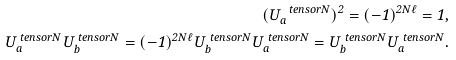Convert formula to latex. <formula><loc_0><loc_0><loc_500><loc_500>( U _ { a } ^ { \ t e n s o r N } ) ^ { 2 } = ( - 1 ) ^ { 2 N \ell } = 1 , \\ U _ { a } ^ { \ t e n s o r N } U _ { b } ^ { \ t e n s o r N } = ( - 1 ) ^ { 2 N \ell } U _ { b } ^ { \ t e n s o r N } U _ { a } ^ { \ t e n s o r N } = U _ { b } ^ { \ t e n s o r N } U _ { a } ^ { \ t e n s o r N } .</formula> 